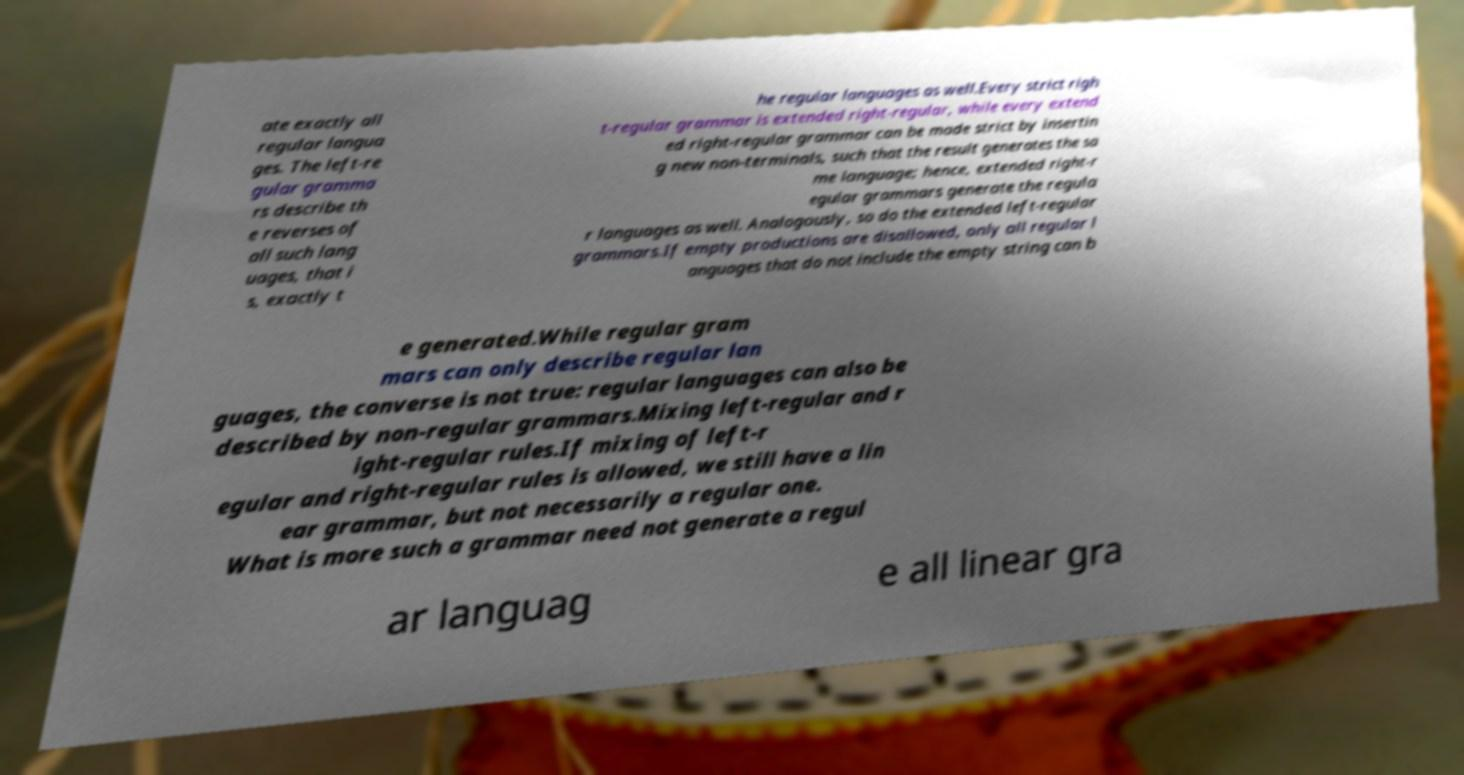I need the written content from this picture converted into text. Can you do that? ate exactly all regular langua ges. The left-re gular gramma rs describe th e reverses of all such lang uages, that i s, exactly t he regular languages as well.Every strict righ t-regular grammar is extended right-regular, while every extend ed right-regular grammar can be made strict by insertin g new non-terminals, such that the result generates the sa me language; hence, extended right-r egular grammars generate the regula r languages as well. Analogously, so do the extended left-regular grammars.If empty productions are disallowed, only all regular l anguages that do not include the empty string can b e generated.While regular gram mars can only describe regular lan guages, the converse is not true: regular languages can also be described by non-regular grammars.Mixing left-regular and r ight-regular rules.If mixing of left-r egular and right-regular rules is allowed, we still have a lin ear grammar, but not necessarily a regular one. What is more such a grammar need not generate a regul ar languag e all linear gra 